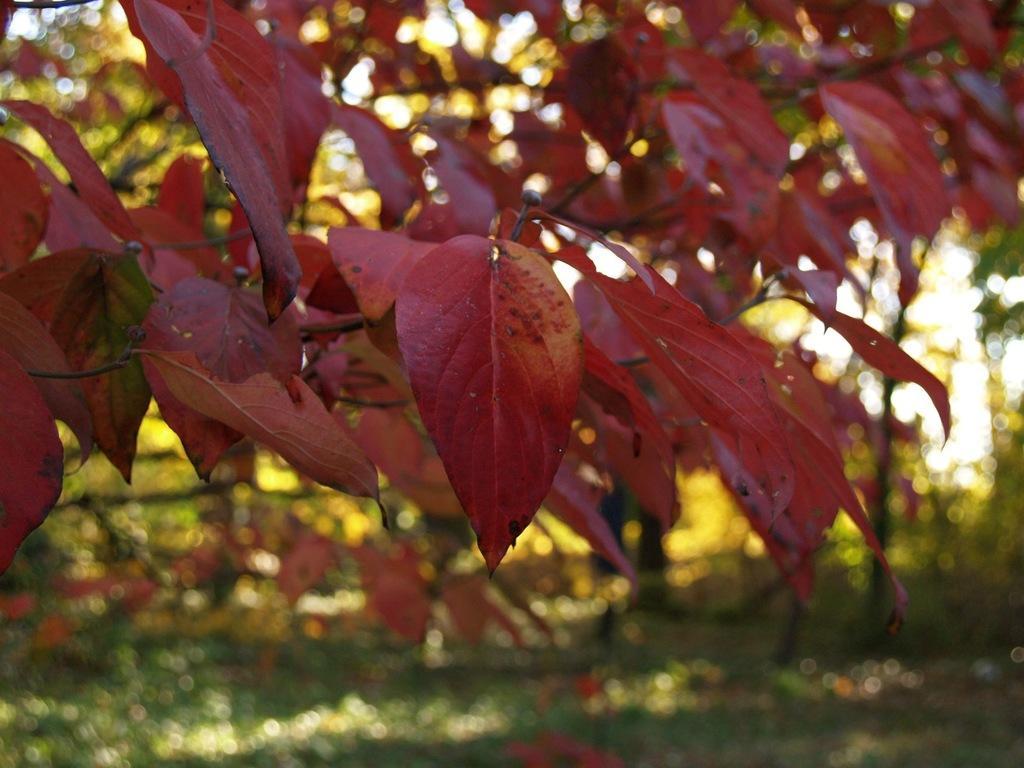Describe this image in one or two sentences. In this image we can see the leaves of a tree. 